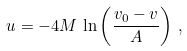Convert formula to latex. <formula><loc_0><loc_0><loc_500><loc_500>u = - 4 M \, \ln \left ( \frac { v _ { 0 } - v } { A } \right ) \, ,</formula> 